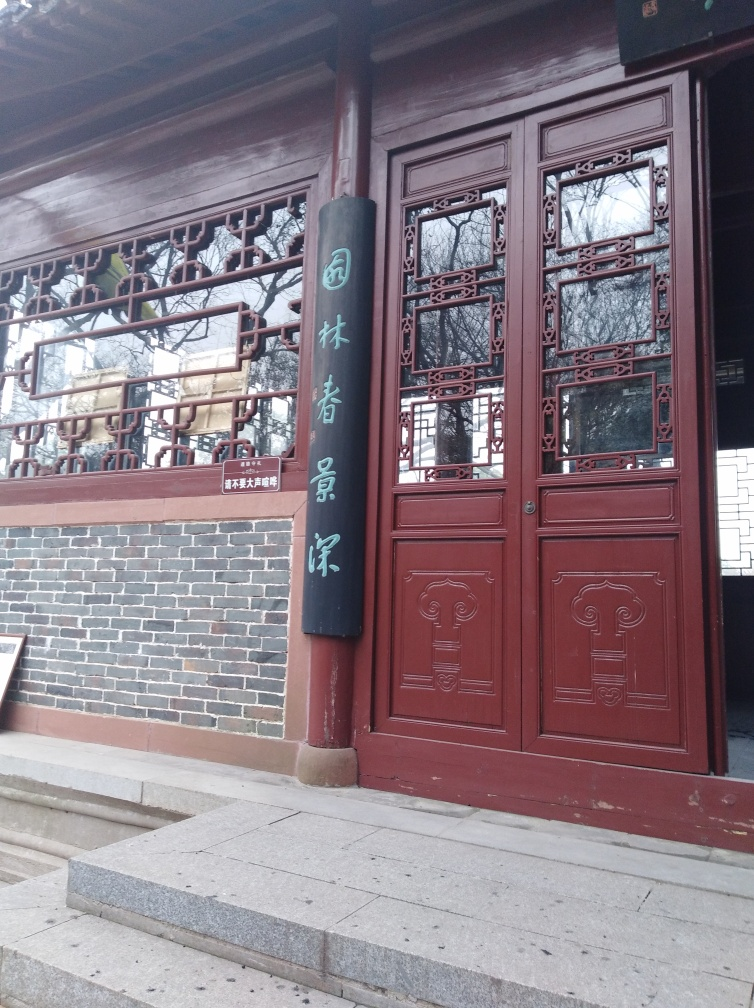Are the colors in the image rich? The image displays a relatively subdued color palette with the focus on the rich earthy tones of the wooden door and the contrasting dark green and white characters on a hanging sign; however, the colors are not particularly saturated or vibrant, but rather convey a sense of traditional elegance and understated beauty. 